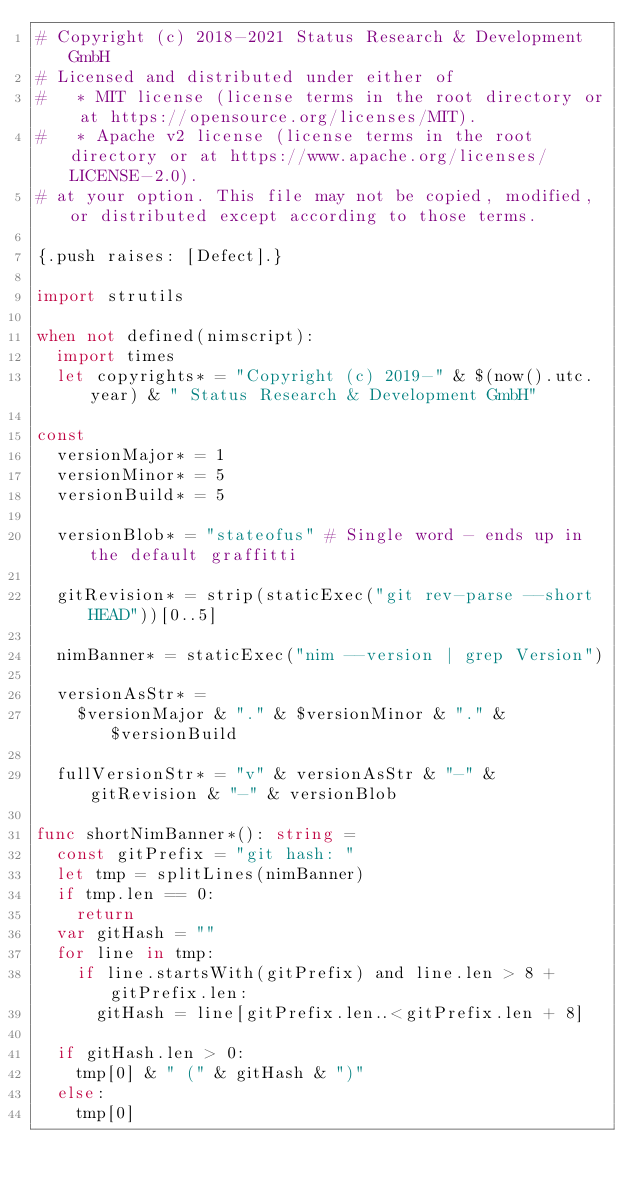<code> <loc_0><loc_0><loc_500><loc_500><_Nim_># Copyright (c) 2018-2021 Status Research & Development GmbH
# Licensed and distributed under either of
#   * MIT license (license terms in the root directory or at https://opensource.org/licenses/MIT).
#   * Apache v2 license (license terms in the root directory or at https://www.apache.org/licenses/LICENSE-2.0).
# at your option. This file may not be copied, modified, or distributed except according to those terms.

{.push raises: [Defect].}

import strutils

when not defined(nimscript):
  import times
  let copyrights* = "Copyright (c) 2019-" & $(now().utc.year) & " Status Research & Development GmbH"

const
  versionMajor* = 1
  versionMinor* = 5
  versionBuild* = 5

  versionBlob* = "stateofus" # Single word - ends up in the default graffitti

  gitRevision* = strip(staticExec("git rev-parse --short HEAD"))[0..5]

  nimBanner* = staticExec("nim --version | grep Version")

  versionAsStr* =
    $versionMajor & "." & $versionMinor & "." & $versionBuild

  fullVersionStr* = "v" & versionAsStr & "-" & gitRevision & "-" & versionBlob

func shortNimBanner*(): string =
  const gitPrefix = "git hash: "
  let tmp = splitLines(nimBanner)
  if tmp.len == 0:
    return
  var gitHash = ""
  for line in tmp:
    if line.startsWith(gitPrefix) and line.len > 8 + gitPrefix.len:
      gitHash = line[gitPrefix.len..<gitPrefix.len + 8]

  if gitHash.len > 0:
    tmp[0] & " (" & gitHash & ")"
  else:
    tmp[0]
</code> 